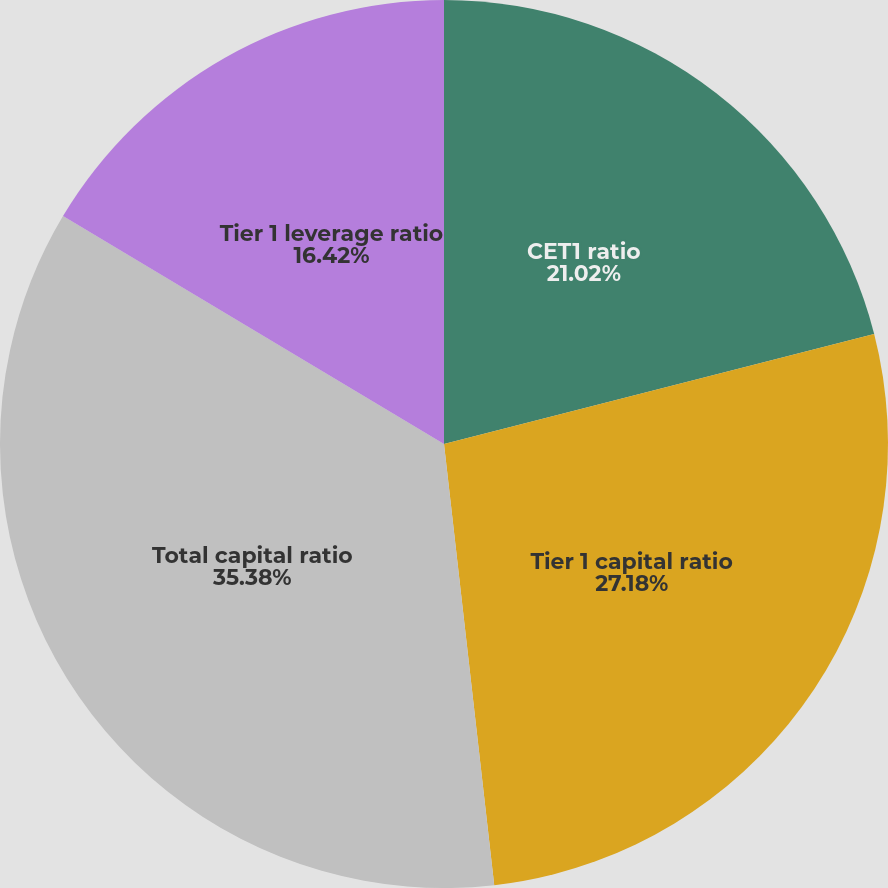Convert chart. <chart><loc_0><loc_0><loc_500><loc_500><pie_chart><fcel>CET1 ratio<fcel>Tier 1 capital ratio<fcel>Total capital ratio<fcel>Tier 1 leverage ratio<nl><fcel>21.02%<fcel>27.18%<fcel>35.39%<fcel>16.42%<nl></chart> 